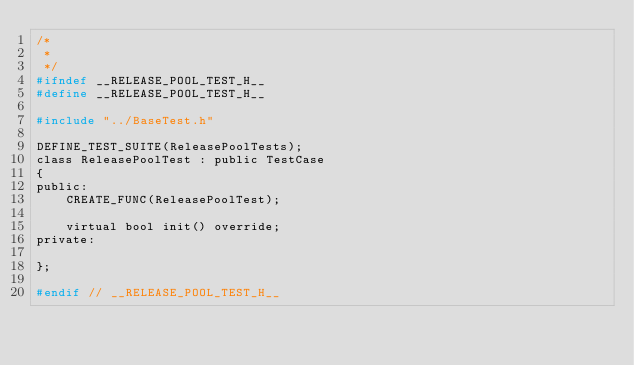<code> <loc_0><loc_0><loc_500><loc_500><_C_>/*
 *
 */
#ifndef __RELEASE_POOL_TEST_H__
#define __RELEASE_POOL_TEST_H__

#include "../BaseTest.h"

DEFINE_TEST_SUITE(ReleasePoolTests);
class ReleasePoolTest : public TestCase
{
public:
    CREATE_FUNC(ReleasePoolTest);

    virtual bool init() override;
private:
    
};

#endif // __RELEASE_POOL_TEST_H__
</code> 